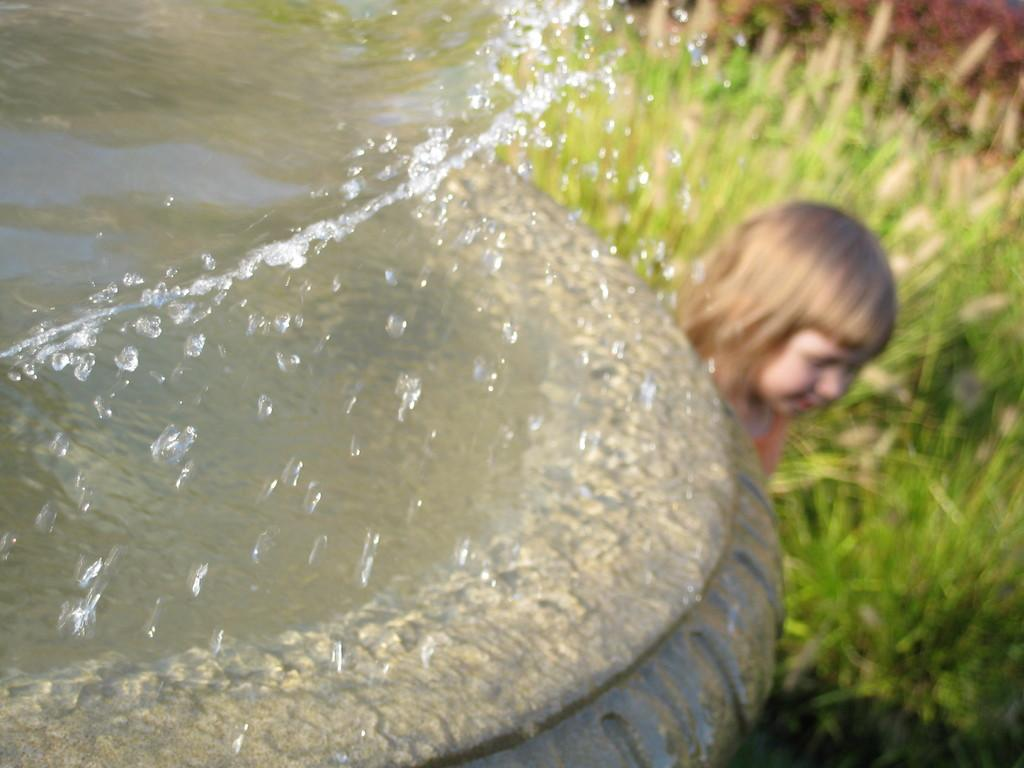What is located in the center of the image? There is water in a container in the center of the image. What can be seen in the background of the image? There is a girl and grass in the background of the image. What type of mine can be seen in the image? There is no mine present in the image. What kind of doll is the girl playing with in the image? There is no doll visible in the image; only the girl and grass are present in the background. 